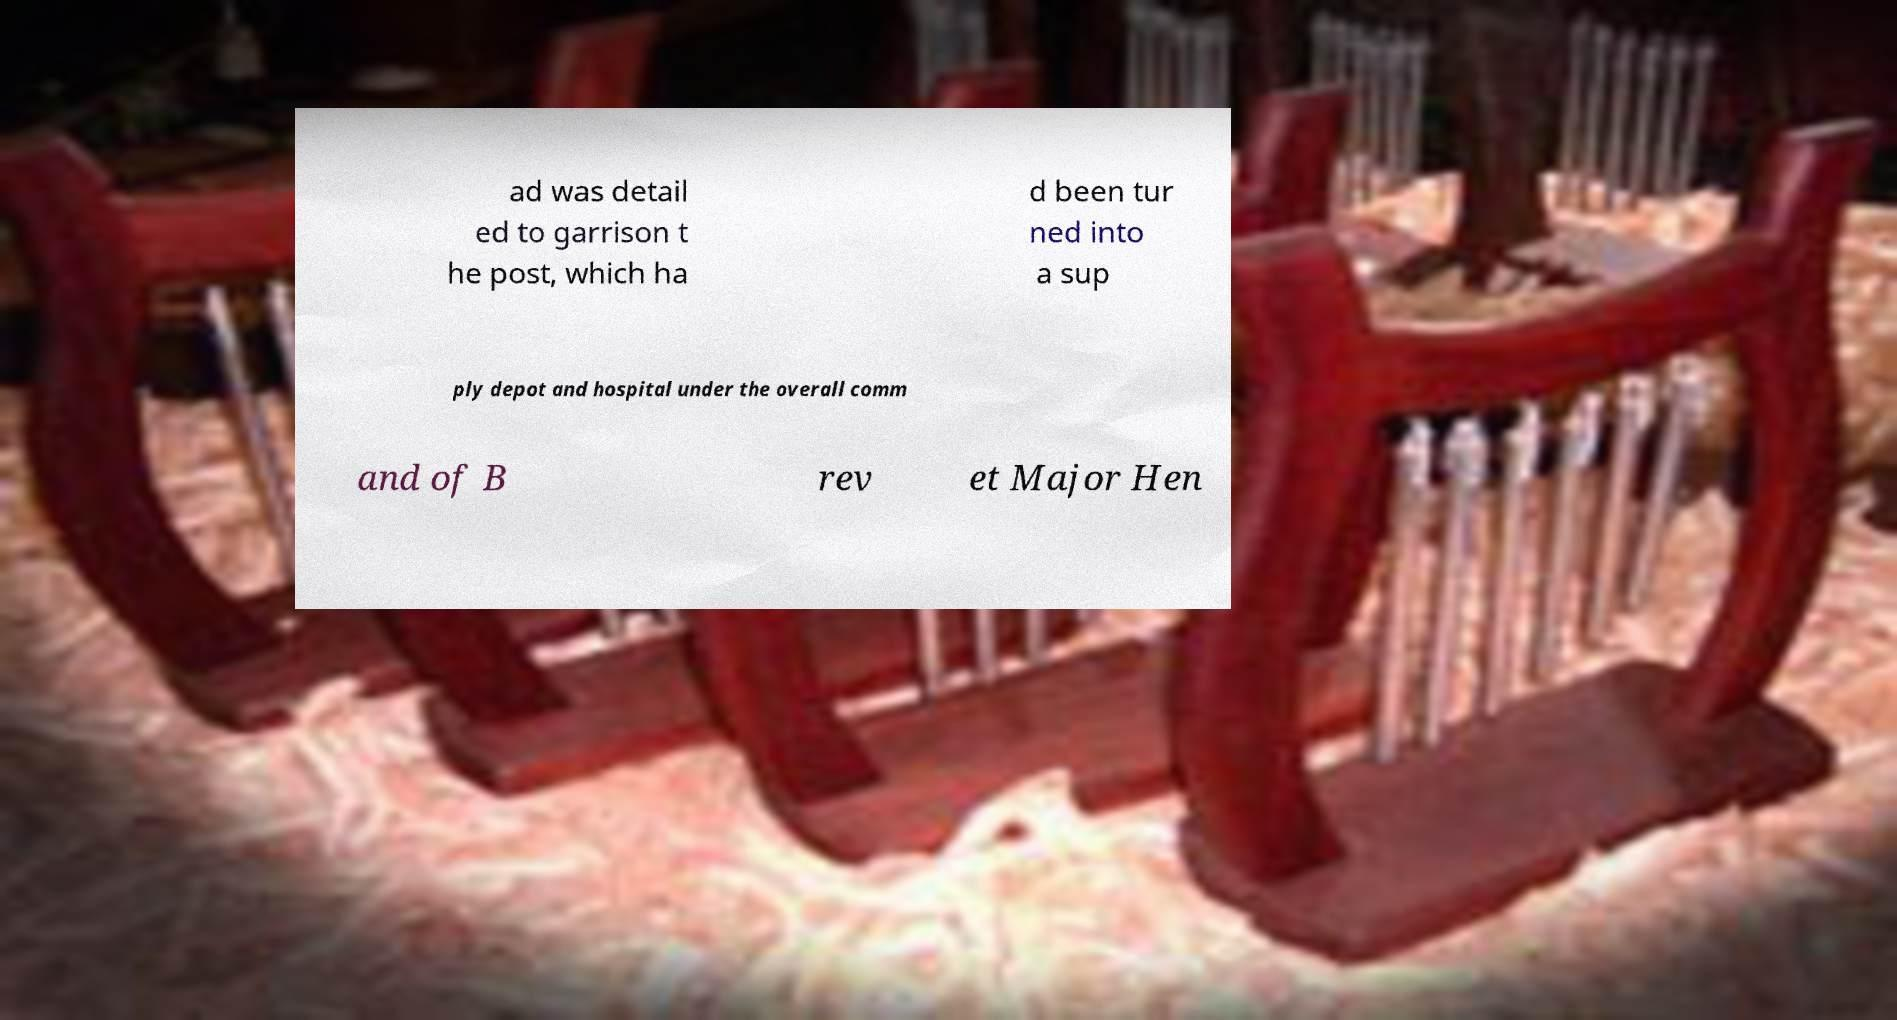Can you read and provide the text displayed in the image?This photo seems to have some interesting text. Can you extract and type it out for me? ad was detail ed to garrison t he post, which ha d been tur ned into a sup ply depot and hospital under the overall comm and of B rev et Major Hen 